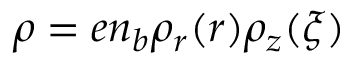Convert formula to latex. <formula><loc_0><loc_0><loc_500><loc_500>\rho = e n _ { b } \rho _ { r } ( r ) \rho _ { z } ( \xi )</formula> 